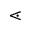Convert formula to latex. <formula><loc_0><loc_0><loc_500><loc_500>\leq s s d o t</formula> 